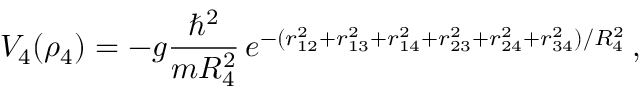<formula> <loc_0><loc_0><loc_500><loc_500>V _ { 4 } ( \rho _ { 4 } ) = - g \frac { \hbar { ^ } { 2 } } { m R _ { 4 } ^ { 2 } } \, e ^ { - ( r _ { 1 2 } ^ { 2 } + r _ { 1 3 } ^ { 2 } + r _ { 1 4 } ^ { 2 } + r _ { 2 3 } ^ { 2 } + r _ { 2 4 } ^ { 2 } + r _ { 3 4 } ^ { 2 } ) / R _ { 4 } ^ { 2 } } \, ,</formula> 